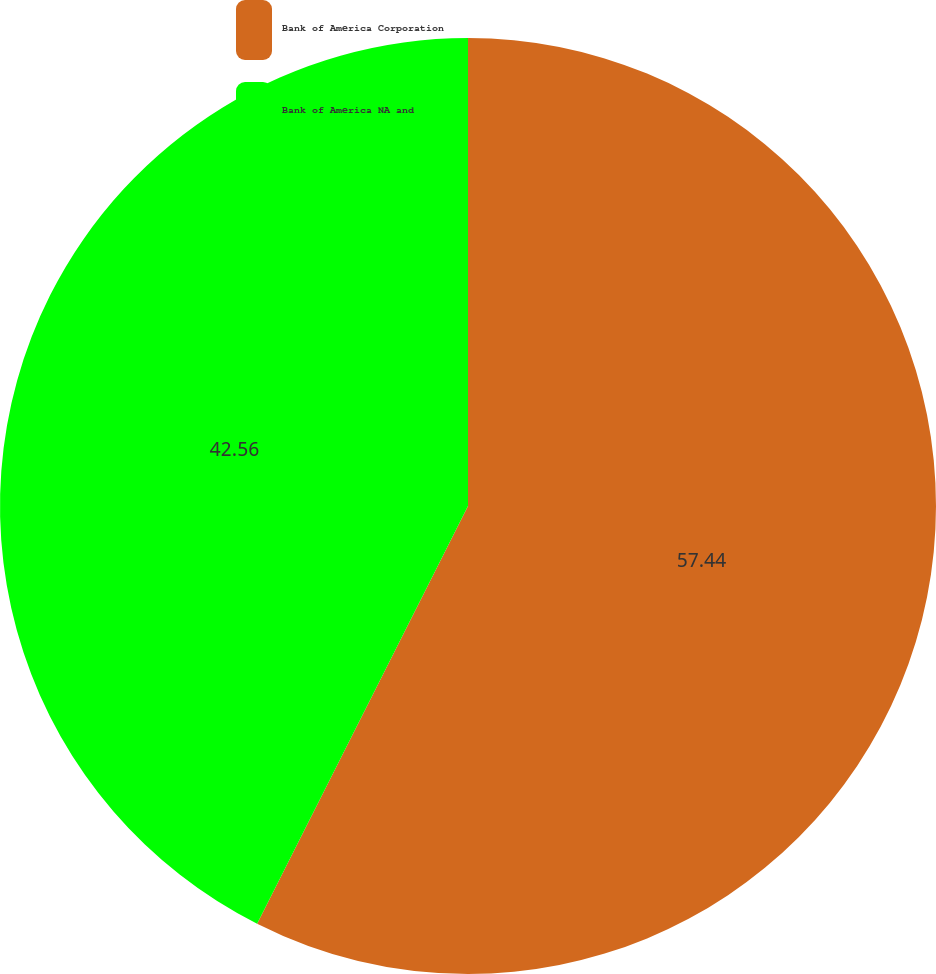Convert chart to OTSL. <chart><loc_0><loc_0><loc_500><loc_500><pie_chart><fcel>Bank of America Corporation<fcel>Bank of America NA and<nl><fcel>57.44%<fcel>42.56%<nl></chart> 